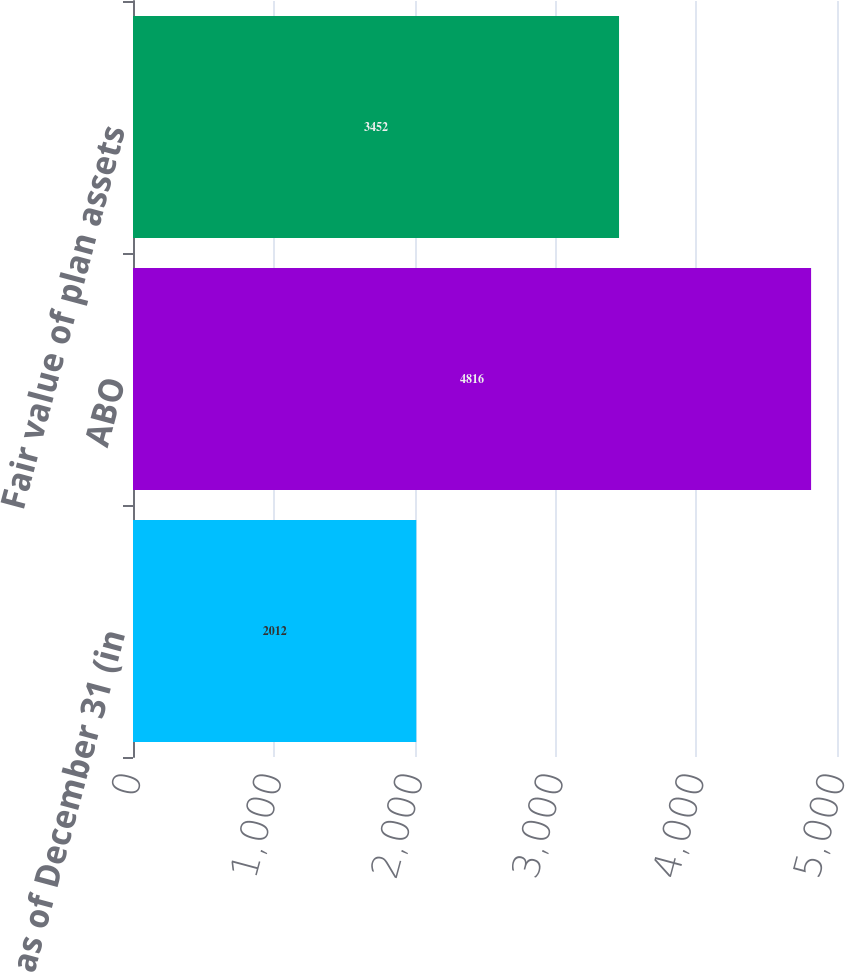Convert chart. <chart><loc_0><loc_0><loc_500><loc_500><bar_chart><fcel>as of December 31 (in<fcel>ABO<fcel>Fair value of plan assets<nl><fcel>2012<fcel>4816<fcel>3452<nl></chart> 